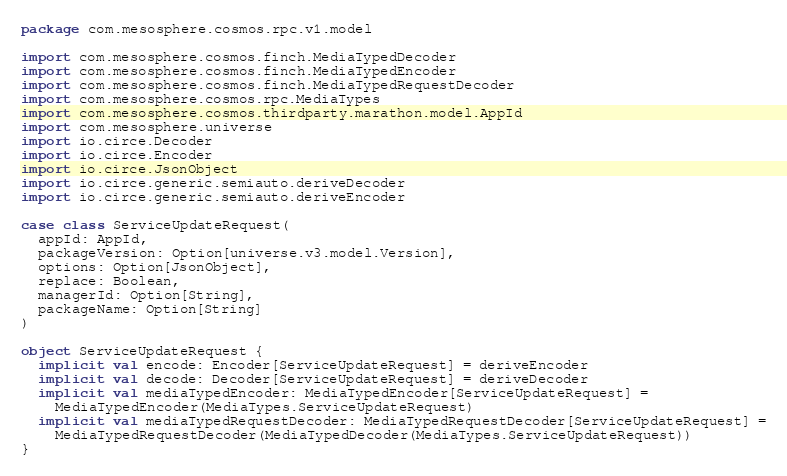Convert code to text. <code><loc_0><loc_0><loc_500><loc_500><_Scala_>package com.mesosphere.cosmos.rpc.v1.model

import com.mesosphere.cosmos.finch.MediaTypedDecoder
import com.mesosphere.cosmos.finch.MediaTypedEncoder
import com.mesosphere.cosmos.finch.MediaTypedRequestDecoder
import com.mesosphere.cosmos.rpc.MediaTypes
import com.mesosphere.cosmos.thirdparty.marathon.model.AppId
import com.mesosphere.universe
import io.circe.Decoder
import io.circe.Encoder
import io.circe.JsonObject
import io.circe.generic.semiauto.deriveDecoder
import io.circe.generic.semiauto.deriveEncoder

case class ServiceUpdateRequest(
  appId: AppId,
  packageVersion: Option[universe.v3.model.Version],
  options: Option[JsonObject],
  replace: Boolean,
  managerId: Option[String],
  packageName: Option[String]
)

object ServiceUpdateRequest {
  implicit val encode: Encoder[ServiceUpdateRequest] = deriveEncoder
  implicit val decode: Decoder[ServiceUpdateRequest] = deriveDecoder
  implicit val mediaTypedEncoder: MediaTypedEncoder[ServiceUpdateRequest] =
    MediaTypedEncoder(MediaTypes.ServiceUpdateRequest)
  implicit val mediaTypedRequestDecoder: MediaTypedRequestDecoder[ServiceUpdateRequest] =
    MediaTypedRequestDecoder(MediaTypedDecoder(MediaTypes.ServiceUpdateRequest))
}
</code> 